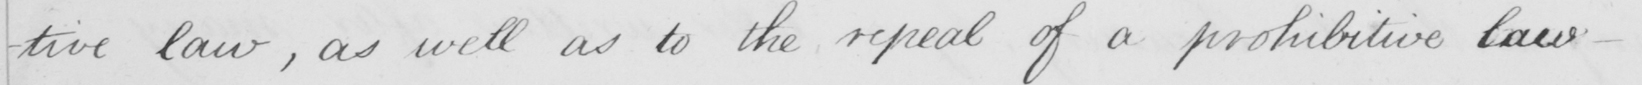What does this handwritten line say? -tive law , as well as to the repeal of a prohibitive law .  _ 